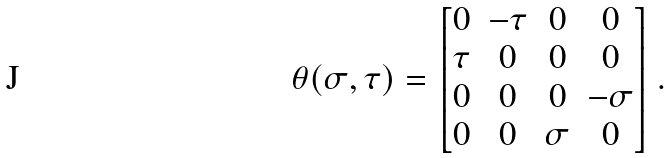Convert formula to latex. <formula><loc_0><loc_0><loc_500><loc_500>\theta ( \sigma , \tau ) = \begin{bmatrix} 0 & - \tau & 0 & 0 \\ \tau & 0 & 0 & 0 \\ 0 & 0 & 0 & - \sigma \\ 0 & 0 & \sigma & 0 \end{bmatrix} .</formula> 